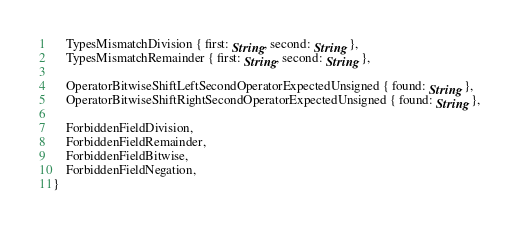Convert code to text. <code><loc_0><loc_0><loc_500><loc_500><_Rust_>    TypesMismatchDivision { first: String, second: String },
    TypesMismatchRemainder { first: String, second: String },

    OperatorBitwiseShiftLeftSecondOperatorExpectedUnsigned { found: String },
    OperatorBitwiseShiftRightSecondOperatorExpectedUnsigned { found: String },

    ForbiddenFieldDivision,
    ForbiddenFieldRemainder,
    ForbiddenFieldBitwise,
    ForbiddenFieldNegation,
}
</code> 